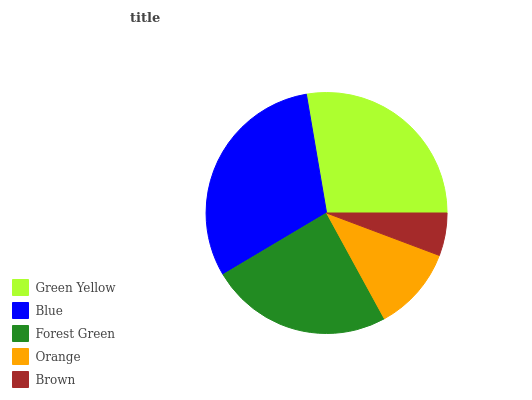Is Brown the minimum?
Answer yes or no. Yes. Is Blue the maximum?
Answer yes or no. Yes. Is Forest Green the minimum?
Answer yes or no. No. Is Forest Green the maximum?
Answer yes or no. No. Is Blue greater than Forest Green?
Answer yes or no. Yes. Is Forest Green less than Blue?
Answer yes or no. Yes. Is Forest Green greater than Blue?
Answer yes or no. No. Is Blue less than Forest Green?
Answer yes or no. No. Is Forest Green the high median?
Answer yes or no. Yes. Is Forest Green the low median?
Answer yes or no. Yes. Is Orange the high median?
Answer yes or no. No. Is Blue the low median?
Answer yes or no. No. 